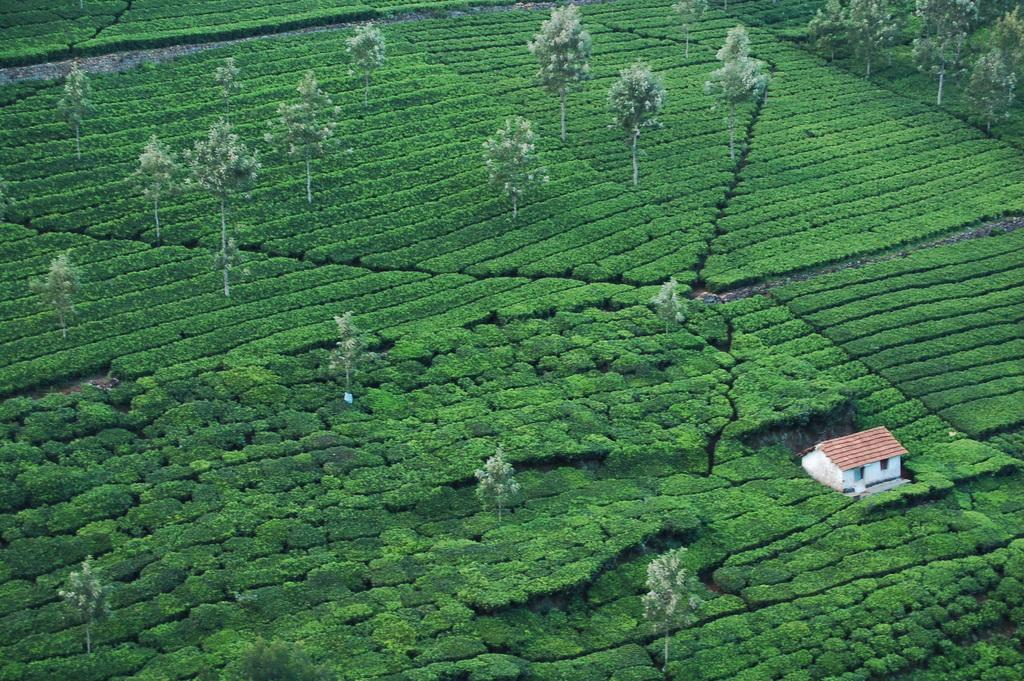What type of living organisms can be seen in the image? Plants and trees are visible in the image. Can any structures be identified in the image? Yes, there is a house present in the image. How many jellyfish are swimming in the image? There are no jellyfish present in the image; it features plants, trees, and a house. What type of love is expressed by the plants in the image? The image does not depict any emotions or expressions of love; it simply shows plants, trees, and a house. 